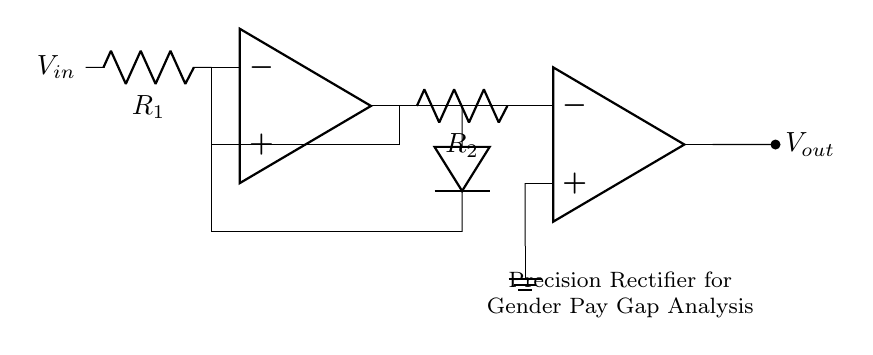What is the purpose of the op-amps in this circuit? The op-amps function as amplifiers for the input signal, enabling precision rectification by producing an output that closely follows the input under certain conditions, particularly for low-voltage signals.
Answer: Amplification What type of diodes are used in this precision rectifier? The diagram does not specify diode types, but precision rectifiers typically utilize fast recovery or Schottky diodes to minimize voltage drop and enhance performance over standard diodes.
Answer: Fast recovery or Schottky How many resistors are present in the circuit? There are two resistors in the circuit indicated as R1 and R2 connected to the op-amps, which are important for setting the gain and the behavior of the circuit.
Answer: Two What is the function of resistor R1 in the circuit? Resistor R1 works as part of the feedback loop for the first op-amp, controlling the gain and determining the input impedance, which is critical for the correct functioning of the precision rectifier.
Answer: Feedback Is the output Vout always positive in this precision rectifier? Yes, the design of the precision rectifier allows the output to swing to positive values even when the input signal is negative, thereby creating a full-wave rectified signal from the input.
Answer: Yes How does this circuit improve measurement accuracy in data acquisition systems? The precision rectifier allows for accurate measurement of both positive and negative input signals with reduced distortion, making it very effective for analyzing small signals, such as those in gender pay gap statistics.
Answer: Improved accuracy What is the significance of the ground connection in this circuit? The ground connection provides a reference point for the circuit, stabilizing the voltage levels and ensuring that the op-amps can accurately process the input signals with respect to a common potential.
Answer: Reference point 